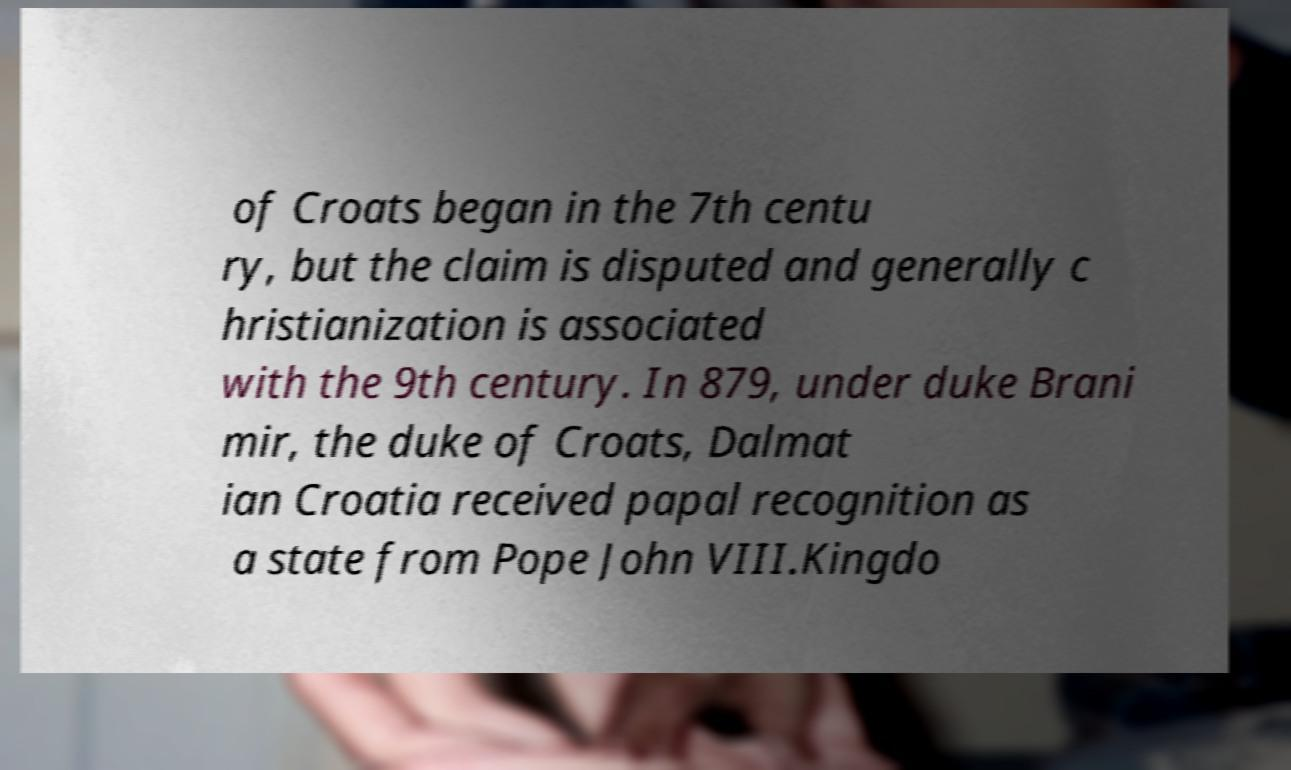Could you assist in decoding the text presented in this image and type it out clearly? of Croats began in the 7th centu ry, but the claim is disputed and generally c hristianization is associated with the 9th century. In 879, under duke Brani mir, the duke of Croats, Dalmat ian Croatia received papal recognition as a state from Pope John VIII.Kingdo 